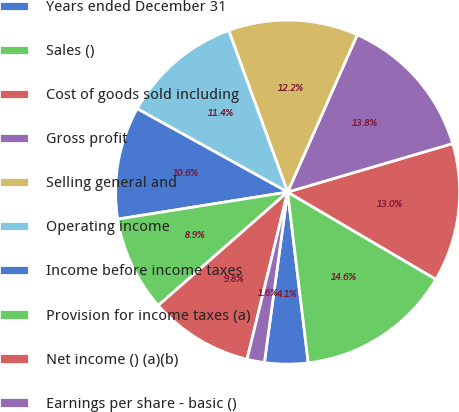Convert chart. <chart><loc_0><loc_0><loc_500><loc_500><pie_chart><fcel>Years ended December 31<fcel>Sales ()<fcel>Cost of goods sold including<fcel>Gross profit<fcel>Selling general and<fcel>Operating income<fcel>Income before income taxes<fcel>Provision for income taxes (a)<fcel>Net income () (a)(b)<fcel>Earnings per share - basic ()<nl><fcel>4.07%<fcel>14.63%<fcel>13.01%<fcel>13.82%<fcel>12.2%<fcel>11.38%<fcel>10.57%<fcel>8.94%<fcel>9.76%<fcel>1.63%<nl></chart> 